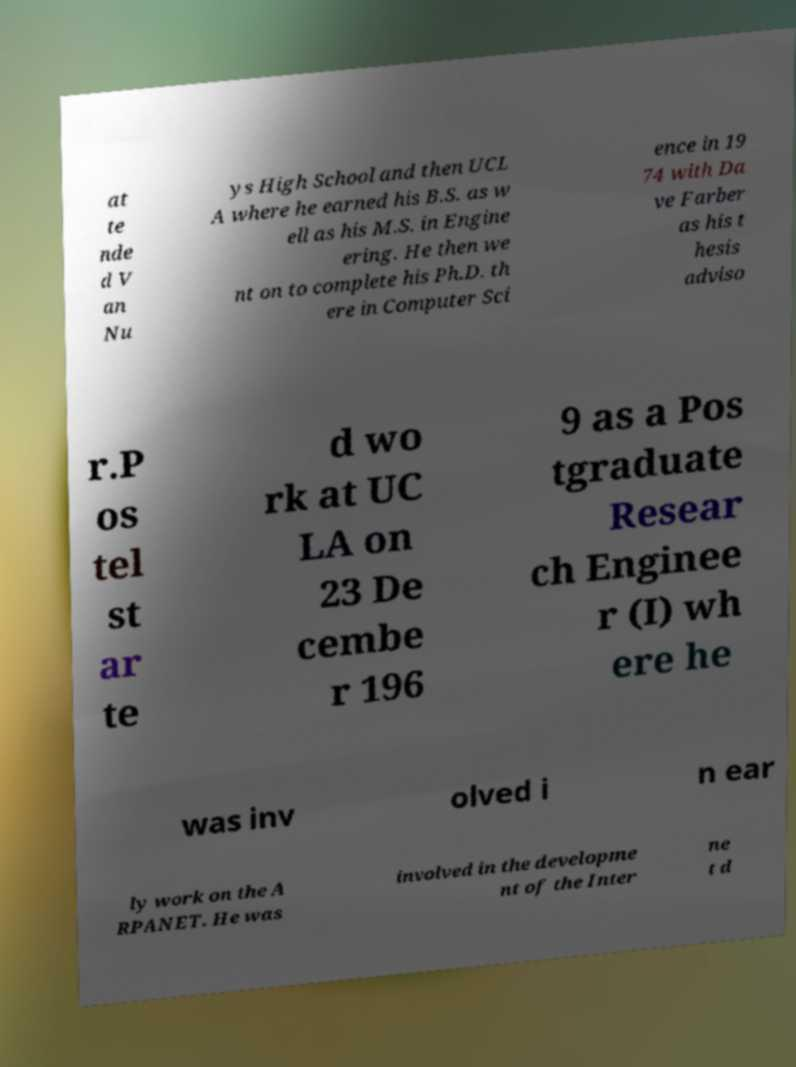I need the written content from this picture converted into text. Can you do that? at te nde d V an Nu ys High School and then UCL A where he earned his B.S. as w ell as his M.S. in Engine ering. He then we nt on to complete his Ph.D. th ere in Computer Sci ence in 19 74 with Da ve Farber as his t hesis adviso r.P os tel st ar te d wo rk at UC LA on 23 De cembe r 196 9 as a Pos tgraduate Resear ch Enginee r (I) wh ere he was inv olved i n ear ly work on the A RPANET. He was involved in the developme nt of the Inter ne t d 